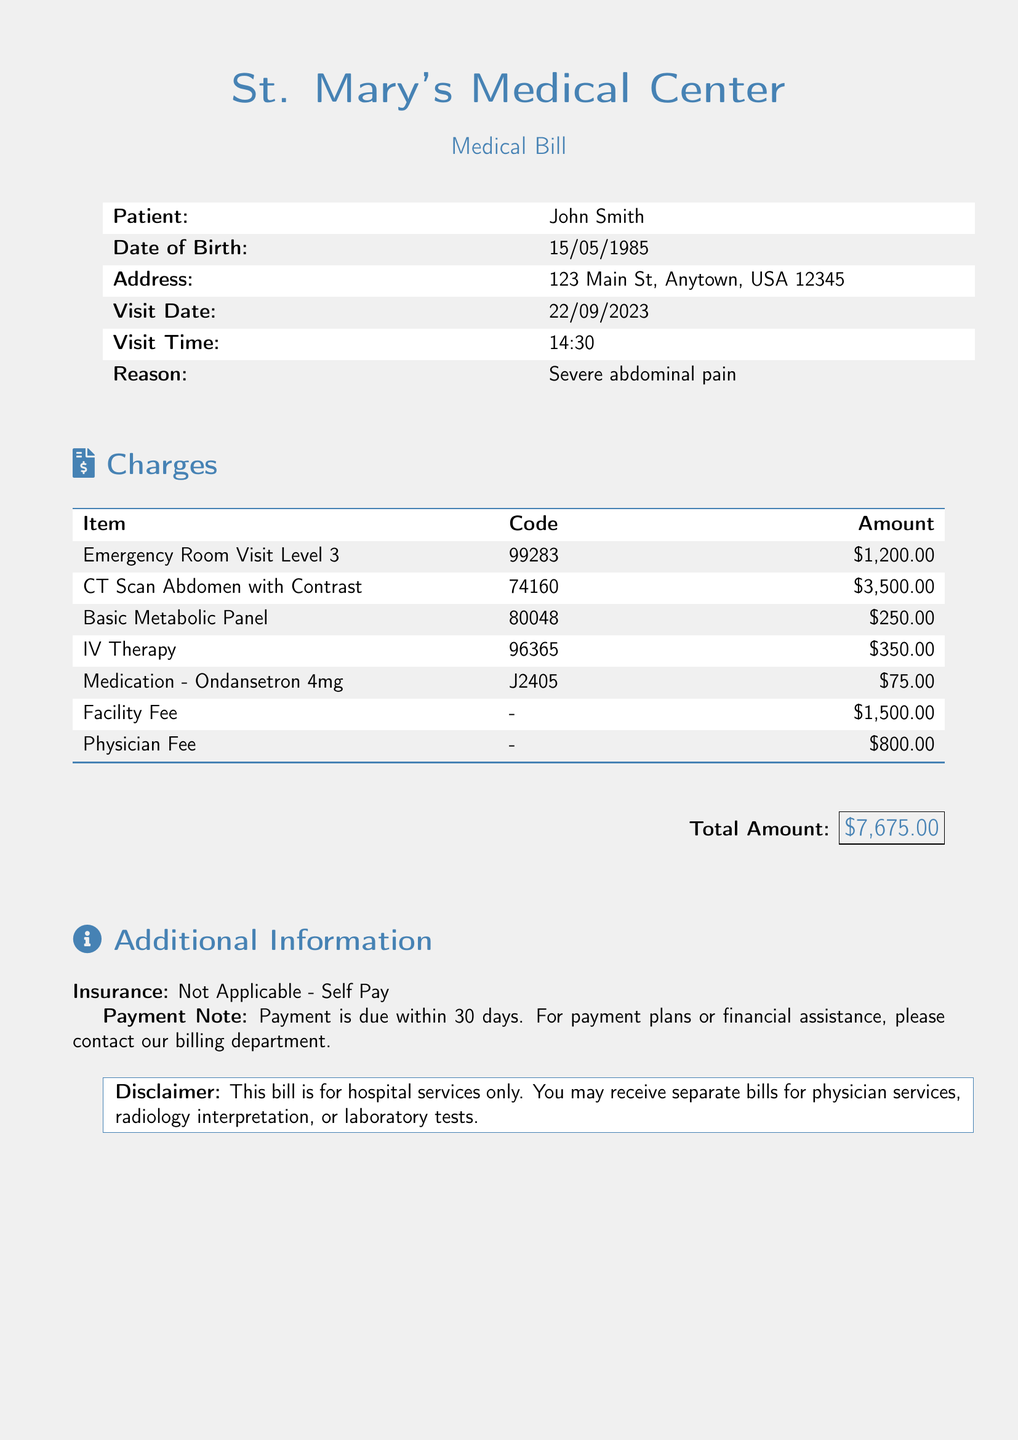what is the total amount due? The total amount due is the amount listed at the bottom of the bill for all services rendered.
Answer: $7,675.00 who is the patient? The patient's name is mentioned at the top of the bill, indicating who received the services.
Answer: John Smith what was the reason for the visit? The reason for the visit is provided in the patient information section of the document.
Answer: Severe abdominal pain what is the charge for the CT scan? The charge for the CT scan is specified next to the item in the charges section.
Answer: $3,500.00 what is the physician fee? The physician fee is one of the charges listed in the document, providing the cost of the physician's services.
Answer: $800.00 what is the code for the Emergency Room Visit? The code is an identifier for the service rendered, found next to the service description.
Answer: 99283 is insurance applicable for this bill? The insurance section indicates whether insurance coverage applies to the services provided in the bill.
Answer: Not Applicable - Self Pay how long does the patient have to pay? The payment note specifies the time frame within which payment is expected.
Answer: 30 days 